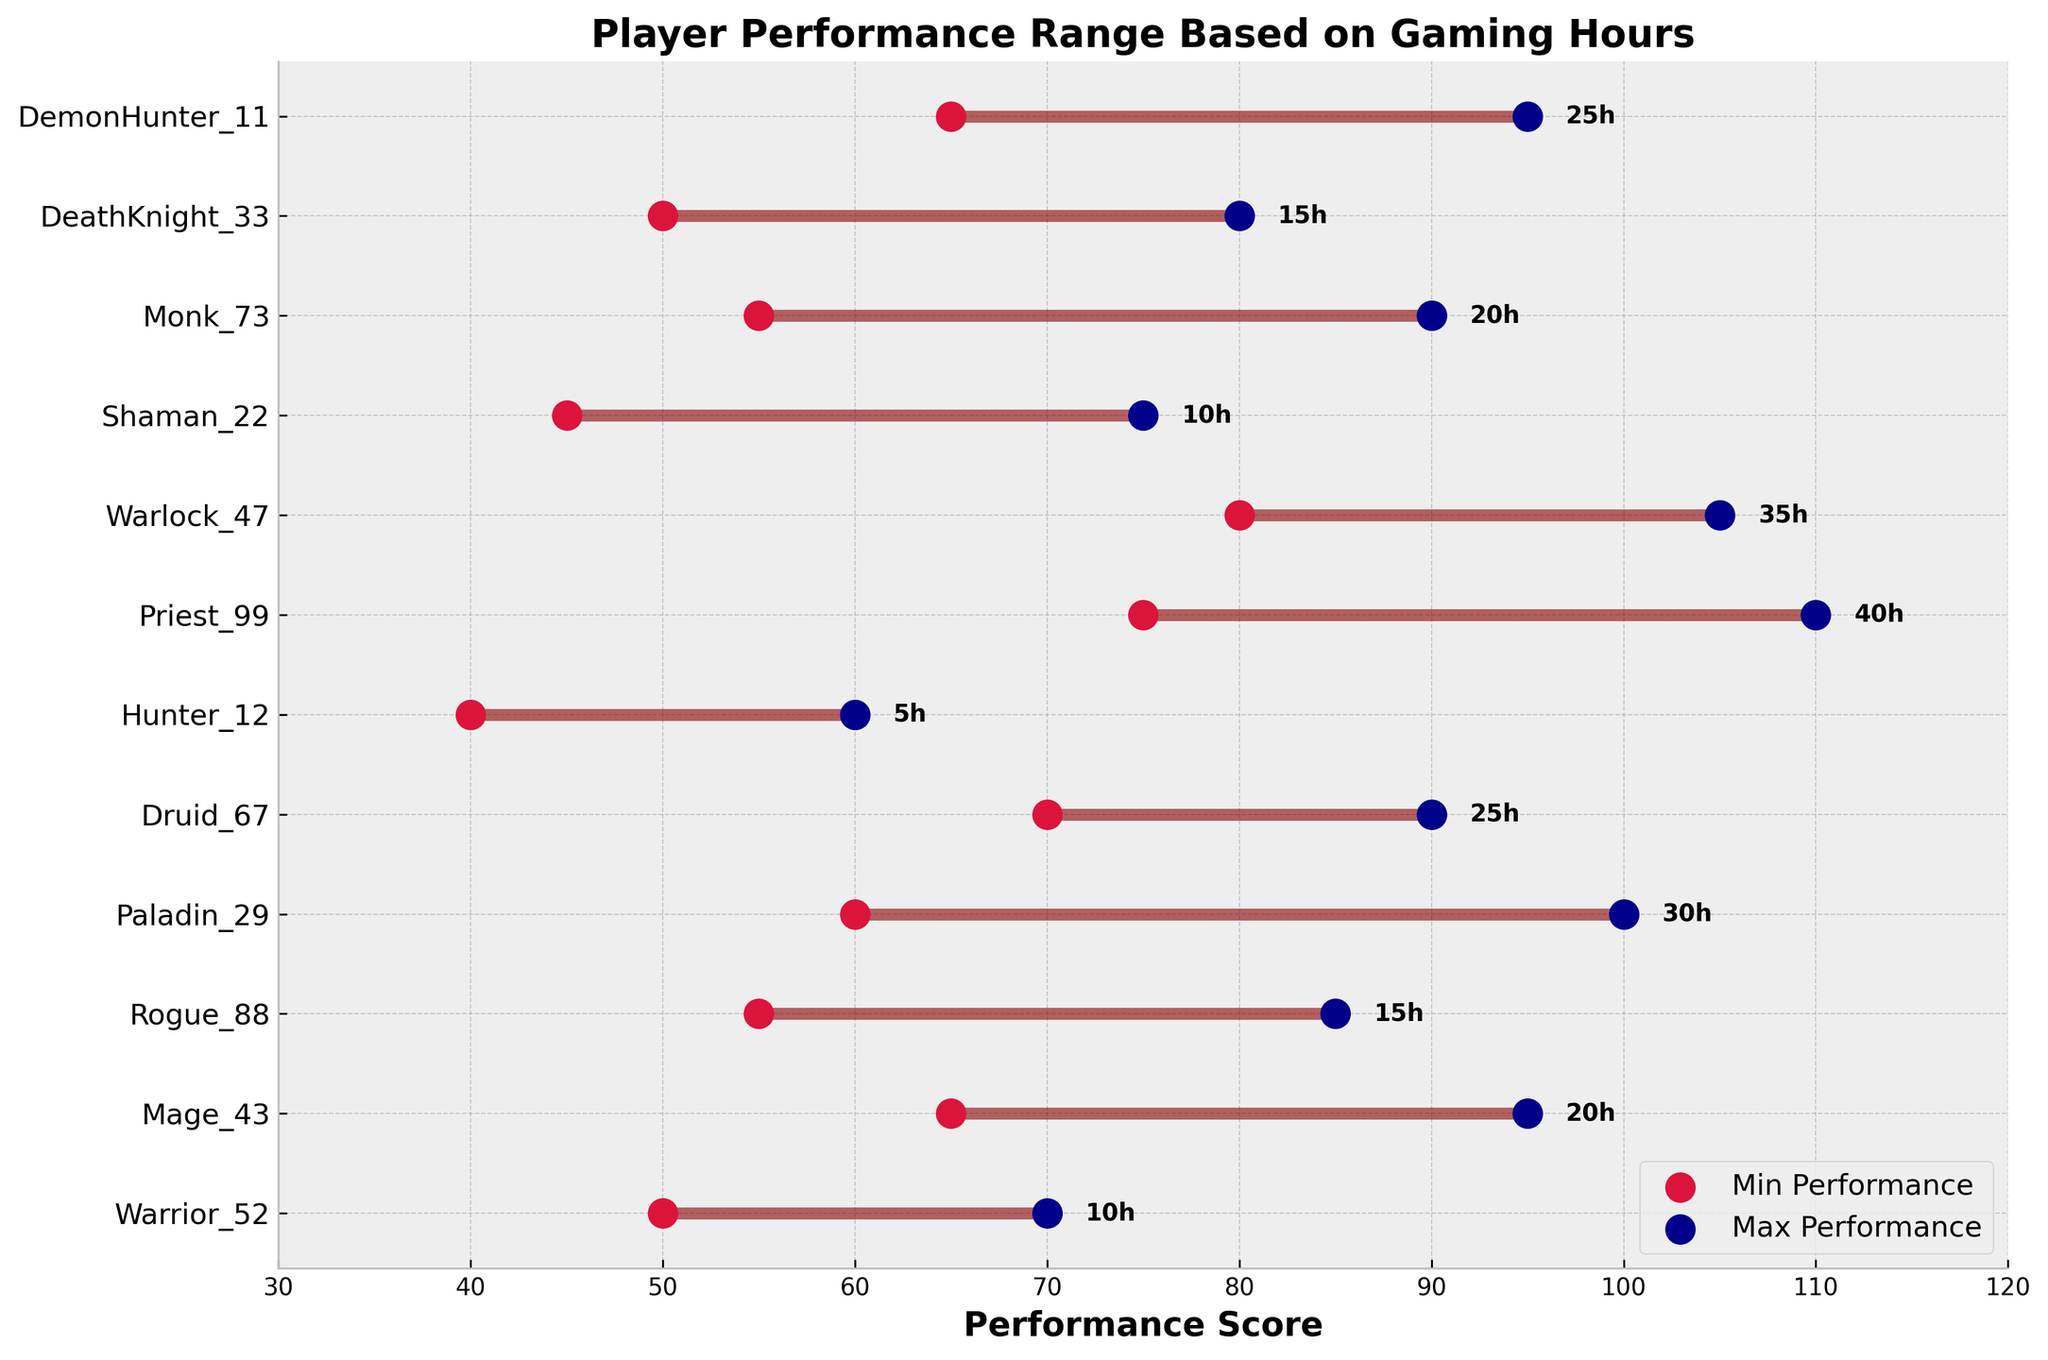what is the title of the figure? The title is located at the top of the figure in bold text. It reads, "Player Performance Range Based on Gaming Hours".
Answer: Player Performance Range Based on Gaming Hours How many players are presented in the figure? The y-axis lists each player's name, and there are markers corresponding to each player. There are 12 players listed on the axis.
Answer: 12 which player has the highest maximum performance score? The maximum performance score is indicated by the rightmost scatter points. The player with the highest maximum performance score is Priest_99 with a score of 110.
Answer: Priest_99 which player has the lowest minimum performance score? The minimum performance score is indicated by the leftmost scatter points. The player with the lowest minimum performance score is Hunter_12 with a score of 40.
Answer: Hunter_12 What's the performance range for Paladin_29? The range can be calculated by subtracting the minimum performance from the maximum performance for Paladin_29. The range is 100 - 60.
Answer: 40 Compare the gaming hours of Mage_43 and Warlock_47. Who has more gaming hours? The gaming hours are written next to the maximum performance score for each player. Mage_43 has 20 hours, and Warlock_47 has 35 hours. Therefore, Warlock_47 has more gaming hours.
Answer: Warlock_47 What's the average minimum performance score of Monk_73 and DemonHunter_11? Add the minimum performance scores of Monk_73 (55) and DemonHunter_11 (65). Then divide by 2: (55 + 65) / 2.
Answer: 60 how many players have a max performance score greater than 100? Players with a maximum performance score greater than 100 have points right of 100 on the x-axis. Those players are Priest_99 and Warlock_47.
Answer: 2 Who has a smaller performance range, Rogue_88 or DeathKnight_33? Calculate the range: Rogue_88 (85-55 = 30) and DeathKnight_33 (80-50 = 30). Since both ranges are equal, neither has a smaller performance range.
Answer: Neither What's the combined total of gaming hours for all players who have a minimum performance of at least 50? The players with a minimum performance score of at least 50 are: Warrior_52 (10h), Mage_43 (20h), Paladin_29 (30h), Druid_67 (25h), Warlock_47 (35h), Monk_73 (20h), DemonHunter_11 (25h). Sum their hours: 10 + 20 + 30 + 25 + 35 + 20 + 25.
Answer: 165 